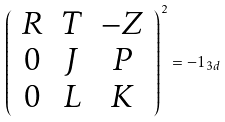<formula> <loc_0><loc_0><loc_500><loc_500>\left ( \begin{array} { c c c } R & T & - Z \\ 0 & J & P \\ 0 & L & K \end{array} \right ) ^ { 2 } = - 1 _ { 3 d }</formula> 